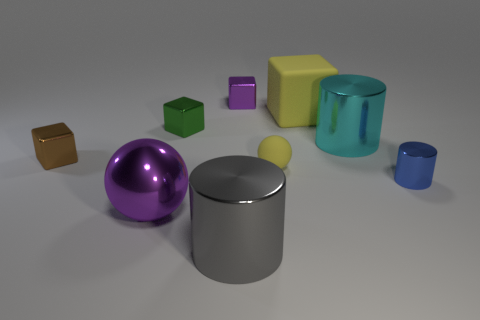Can you tell me the different shapes and colors of the objects present in the image? Certainly! The image features a variety of shapes including cylinders, spheres, and cubes. The colors present are purple, yellow, green, blue, and brown. Specifically, there is a large purple sphere, a small and a large cylinder in metallic silver, a small yellow cube, a yellowish-green matte block, a small green cube, a blue transparent cylinder, and a small brown metallic cube. 